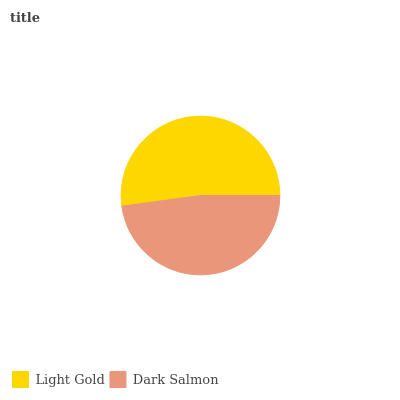Is Dark Salmon the minimum?
Answer yes or no. Yes. Is Light Gold the maximum?
Answer yes or no. Yes. Is Dark Salmon the maximum?
Answer yes or no. No. Is Light Gold greater than Dark Salmon?
Answer yes or no. Yes. Is Dark Salmon less than Light Gold?
Answer yes or no. Yes. Is Dark Salmon greater than Light Gold?
Answer yes or no. No. Is Light Gold less than Dark Salmon?
Answer yes or no. No. Is Light Gold the high median?
Answer yes or no. Yes. Is Dark Salmon the low median?
Answer yes or no. Yes. Is Dark Salmon the high median?
Answer yes or no. No. Is Light Gold the low median?
Answer yes or no. No. 